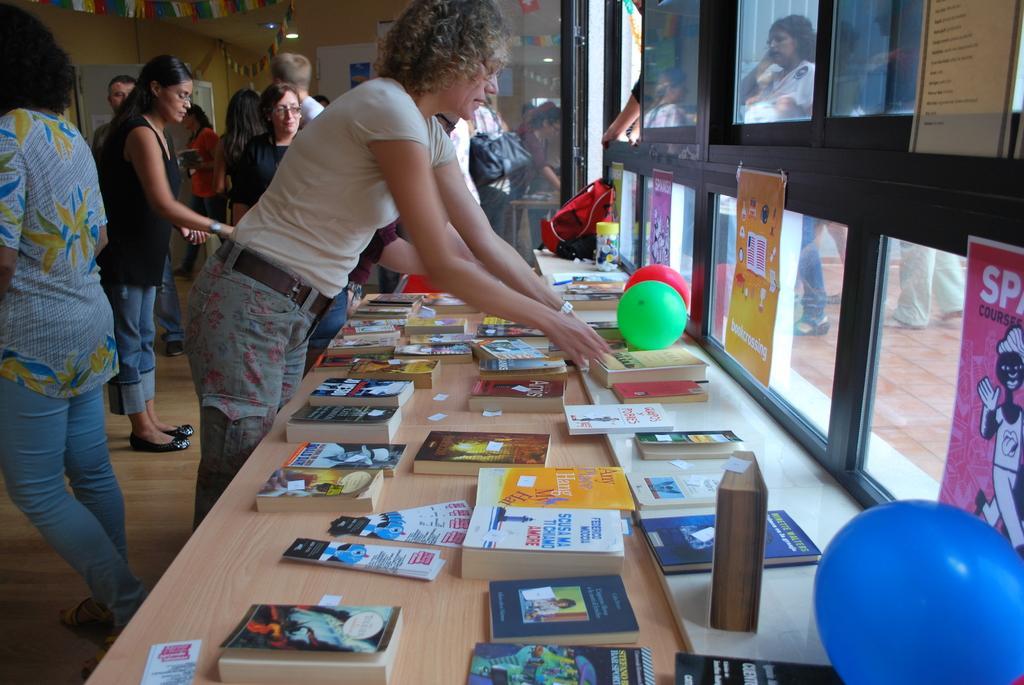In one or two sentences, can you explain what this image depicts? This image consists of many books and it is looking like a book store. In the background on the left there are many people looking for books in the foreground in the middle of the image there are many books placed on the table. On the right of the image there are balloons in the center of the image also. In the background there is a backpack. In the center of the image there is a woman wearing a cream color shirt adjusting books. In the background on the left there are ribbons hanging and to the right there is a window. 